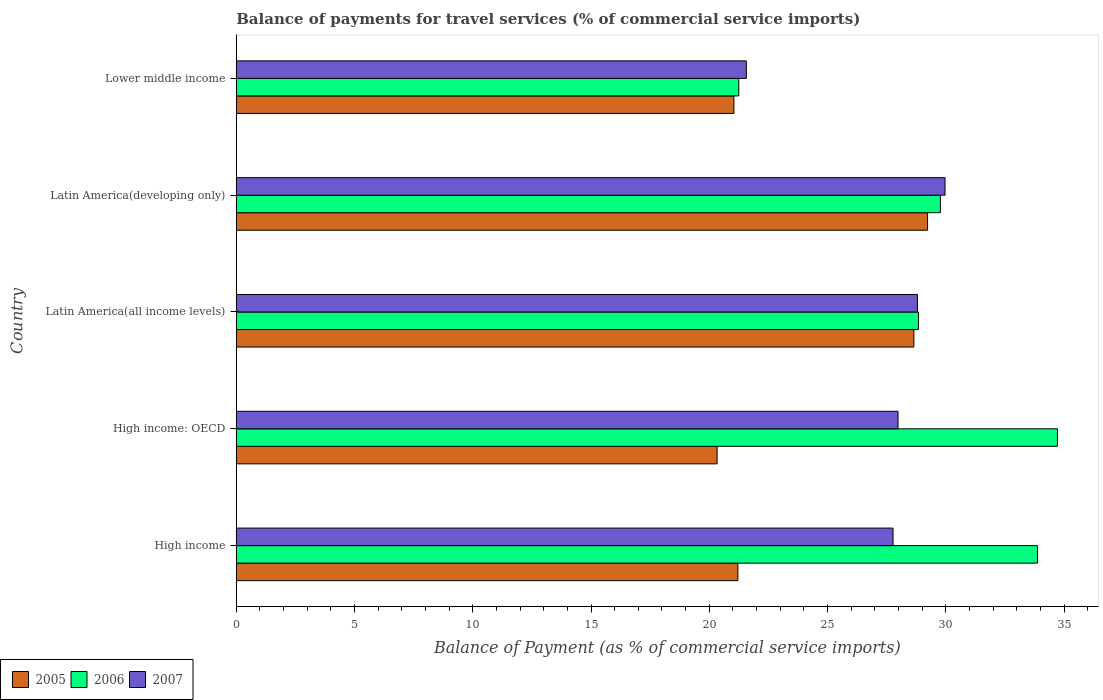What is the label of the 4th group of bars from the top?
Your response must be concise. High income: OECD. In how many cases, is the number of bars for a given country not equal to the number of legend labels?
Make the answer very short. 0. What is the balance of payments for travel services in 2006 in High income?
Your response must be concise. 33.88. Across all countries, what is the maximum balance of payments for travel services in 2005?
Provide a short and direct response. 29.23. Across all countries, what is the minimum balance of payments for travel services in 2007?
Keep it short and to the point. 21.57. In which country was the balance of payments for travel services in 2006 maximum?
Your answer should be compact. High income: OECD. In which country was the balance of payments for travel services in 2005 minimum?
Make the answer very short. High income: OECD. What is the total balance of payments for travel services in 2007 in the graph?
Keep it short and to the point. 136.08. What is the difference between the balance of payments for travel services in 2006 in High income and that in High income: OECD?
Make the answer very short. -0.84. What is the difference between the balance of payments for travel services in 2005 in Latin America(all income levels) and the balance of payments for travel services in 2007 in Latin America(developing only)?
Make the answer very short. -1.32. What is the average balance of payments for travel services in 2006 per country?
Ensure brevity in your answer.  29.69. What is the difference between the balance of payments for travel services in 2006 and balance of payments for travel services in 2007 in High income: OECD?
Your answer should be compact. 6.74. In how many countries, is the balance of payments for travel services in 2005 greater than 23 %?
Ensure brevity in your answer.  2. What is the ratio of the balance of payments for travel services in 2005 in Latin America(all income levels) to that in Lower middle income?
Your answer should be very brief. 1.36. Is the balance of payments for travel services in 2006 in Latin America(all income levels) less than that in Latin America(developing only)?
Provide a succinct answer. Yes. Is the difference between the balance of payments for travel services in 2006 in High income: OECD and Latin America(all income levels) greater than the difference between the balance of payments for travel services in 2007 in High income: OECD and Latin America(all income levels)?
Provide a succinct answer. Yes. What is the difference between the highest and the second highest balance of payments for travel services in 2007?
Provide a succinct answer. 1.17. What is the difference between the highest and the lowest balance of payments for travel services in 2007?
Ensure brevity in your answer.  8.4. How many countries are there in the graph?
Give a very brief answer. 5. Does the graph contain grids?
Ensure brevity in your answer.  No. How many legend labels are there?
Your response must be concise. 3. What is the title of the graph?
Give a very brief answer. Balance of payments for travel services (% of commercial service imports). What is the label or title of the X-axis?
Your answer should be very brief. Balance of Payment (as % of commercial service imports). What is the Balance of Payment (as % of commercial service imports) in 2005 in High income?
Offer a very short reply. 21.21. What is the Balance of Payment (as % of commercial service imports) in 2006 in High income?
Keep it short and to the point. 33.88. What is the Balance of Payment (as % of commercial service imports) of 2007 in High income?
Provide a succinct answer. 27.77. What is the Balance of Payment (as % of commercial service imports) of 2005 in High income: OECD?
Make the answer very short. 20.33. What is the Balance of Payment (as % of commercial service imports) in 2006 in High income: OECD?
Give a very brief answer. 34.72. What is the Balance of Payment (as % of commercial service imports) in 2007 in High income: OECD?
Make the answer very short. 27.98. What is the Balance of Payment (as % of commercial service imports) of 2005 in Latin America(all income levels)?
Your answer should be very brief. 28.65. What is the Balance of Payment (as % of commercial service imports) of 2006 in Latin America(all income levels)?
Your answer should be compact. 28.84. What is the Balance of Payment (as % of commercial service imports) of 2007 in Latin America(all income levels)?
Your answer should be very brief. 28.8. What is the Balance of Payment (as % of commercial service imports) of 2005 in Latin America(developing only)?
Offer a terse response. 29.23. What is the Balance of Payment (as % of commercial service imports) of 2006 in Latin America(developing only)?
Ensure brevity in your answer.  29.77. What is the Balance of Payment (as % of commercial service imports) in 2007 in Latin America(developing only)?
Your response must be concise. 29.97. What is the Balance of Payment (as % of commercial service imports) of 2005 in Lower middle income?
Give a very brief answer. 21.04. What is the Balance of Payment (as % of commercial service imports) in 2006 in Lower middle income?
Keep it short and to the point. 21.25. What is the Balance of Payment (as % of commercial service imports) of 2007 in Lower middle income?
Provide a short and direct response. 21.57. Across all countries, what is the maximum Balance of Payment (as % of commercial service imports) of 2005?
Ensure brevity in your answer.  29.23. Across all countries, what is the maximum Balance of Payment (as % of commercial service imports) of 2006?
Provide a succinct answer. 34.72. Across all countries, what is the maximum Balance of Payment (as % of commercial service imports) in 2007?
Ensure brevity in your answer.  29.97. Across all countries, what is the minimum Balance of Payment (as % of commercial service imports) of 2005?
Make the answer very short. 20.33. Across all countries, what is the minimum Balance of Payment (as % of commercial service imports) of 2006?
Your answer should be very brief. 21.25. Across all countries, what is the minimum Balance of Payment (as % of commercial service imports) of 2007?
Your response must be concise. 21.57. What is the total Balance of Payment (as % of commercial service imports) in 2005 in the graph?
Keep it short and to the point. 120.46. What is the total Balance of Payment (as % of commercial service imports) of 2006 in the graph?
Your answer should be very brief. 148.46. What is the total Balance of Payment (as % of commercial service imports) of 2007 in the graph?
Offer a terse response. 136.08. What is the difference between the Balance of Payment (as % of commercial service imports) in 2005 in High income and that in High income: OECD?
Your answer should be compact. 0.88. What is the difference between the Balance of Payment (as % of commercial service imports) in 2006 in High income and that in High income: OECD?
Provide a short and direct response. -0.84. What is the difference between the Balance of Payment (as % of commercial service imports) of 2007 in High income and that in High income: OECD?
Offer a very short reply. -0.21. What is the difference between the Balance of Payment (as % of commercial service imports) of 2005 in High income and that in Latin America(all income levels)?
Provide a succinct answer. -7.44. What is the difference between the Balance of Payment (as % of commercial service imports) in 2006 in High income and that in Latin America(all income levels)?
Provide a succinct answer. 5.03. What is the difference between the Balance of Payment (as % of commercial service imports) of 2007 in High income and that in Latin America(all income levels)?
Ensure brevity in your answer.  -1.03. What is the difference between the Balance of Payment (as % of commercial service imports) of 2005 in High income and that in Latin America(developing only)?
Ensure brevity in your answer.  -8.02. What is the difference between the Balance of Payment (as % of commercial service imports) in 2006 in High income and that in Latin America(developing only)?
Offer a very short reply. 4.1. What is the difference between the Balance of Payment (as % of commercial service imports) of 2007 in High income and that in Latin America(developing only)?
Offer a terse response. -2.2. What is the difference between the Balance of Payment (as % of commercial service imports) of 2005 in High income and that in Lower middle income?
Give a very brief answer. 0.17. What is the difference between the Balance of Payment (as % of commercial service imports) in 2006 in High income and that in Lower middle income?
Your response must be concise. 12.63. What is the difference between the Balance of Payment (as % of commercial service imports) in 2007 in High income and that in Lower middle income?
Offer a terse response. 6.2. What is the difference between the Balance of Payment (as % of commercial service imports) in 2005 in High income: OECD and that in Latin America(all income levels)?
Provide a succinct answer. -8.32. What is the difference between the Balance of Payment (as % of commercial service imports) of 2006 in High income: OECD and that in Latin America(all income levels)?
Make the answer very short. 5.88. What is the difference between the Balance of Payment (as % of commercial service imports) in 2007 in High income: OECD and that in Latin America(all income levels)?
Provide a succinct answer. -0.82. What is the difference between the Balance of Payment (as % of commercial service imports) in 2005 in High income: OECD and that in Latin America(developing only)?
Offer a terse response. -8.9. What is the difference between the Balance of Payment (as % of commercial service imports) in 2006 in High income: OECD and that in Latin America(developing only)?
Make the answer very short. 4.95. What is the difference between the Balance of Payment (as % of commercial service imports) of 2007 in High income: OECD and that in Latin America(developing only)?
Keep it short and to the point. -1.99. What is the difference between the Balance of Payment (as % of commercial service imports) in 2005 in High income: OECD and that in Lower middle income?
Your response must be concise. -0.71. What is the difference between the Balance of Payment (as % of commercial service imports) in 2006 in High income: OECD and that in Lower middle income?
Provide a succinct answer. 13.47. What is the difference between the Balance of Payment (as % of commercial service imports) of 2007 in High income: OECD and that in Lower middle income?
Ensure brevity in your answer.  6.41. What is the difference between the Balance of Payment (as % of commercial service imports) in 2005 in Latin America(all income levels) and that in Latin America(developing only)?
Offer a very short reply. -0.58. What is the difference between the Balance of Payment (as % of commercial service imports) in 2006 in Latin America(all income levels) and that in Latin America(developing only)?
Offer a very short reply. -0.93. What is the difference between the Balance of Payment (as % of commercial service imports) of 2007 in Latin America(all income levels) and that in Latin America(developing only)?
Keep it short and to the point. -1.17. What is the difference between the Balance of Payment (as % of commercial service imports) in 2005 in Latin America(all income levels) and that in Lower middle income?
Ensure brevity in your answer.  7.61. What is the difference between the Balance of Payment (as % of commercial service imports) of 2006 in Latin America(all income levels) and that in Lower middle income?
Offer a terse response. 7.6. What is the difference between the Balance of Payment (as % of commercial service imports) in 2007 in Latin America(all income levels) and that in Lower middle income?
Give a very brief answer. 7.23. What is the difference between the Balance of Payment (as % of commercial service imports) of 2005 in Latin America(developing only) and that in Lower middle income?
Ensure brevity in your answer.  8.19. What is the difference between the Balance of Payment (as % of commercial service imports) in 2006 in Latin America(developing only) and that in Lower middle income?
Your response must be concise. 8.53. What is the difference between the Balance of Payment (as % of commercial service imports) of 2007 in Latin America(developing only) and that in Lower middle income?
Keep it short and to the point. 8.4. What is the difference between the Balance of Payment (as % of commercial service imports) in 2005 in High income and the Balance of Payment (as % of commercial service imports) in 2006 in High income: OECD?
Provide a short and direct response. -13.51. What is the difference between the Balance of Payment (as % of commercial service imports) in 2005 in High income and the Balance of Payment (as % of commercial service imports) in 2007 in High income: OECD?
Your answer should be compact. -6.77. What is the difference between the Balance of Payment (as % of commercial service imports) in 2006 in High income and the Balance of Payment (as % of commercial service imports) in 2007 in High income: OECD?
Your response must be concise. 5.9. What is the difference between the Balance of Payment (as % of commercial service imports) of 2005 in High income and the Balance of Payment (as % of commercial service imports) of 2006 in Latin America(all income levels)?
Provide a succinct answer. -7.63. What is the difference between the Balance of Payment (as % of commercial service imports) in 2005 in High income and the Balance of Payment (as % of commercial service imports) in 2007 in Latin America(all income levels)?
Offer a very short reply. -7.59. What is the difference between the Balance of Payment (as % of commercial service imports) of 2006 in High income and the Balance of Payment (as % of commercial service imports) of 2007 in Latin America(all income levels)?
Offer a very short reply. 5.08. What is the difference between the Balance of Payment (as % of commercial service imports) in 2005 in High income and the Balance of Payment (as % of commercial service imports) in 2006 in Latin America(developing only)?
Ensure brevity in your answer.  -8.56. What is the difference between the Balance of Payment (as % of commercial service imports) of 2005 in High income and the Balance of Payment (as % of commercial service imports) of 2007 in Latin America(developing only)?
Your answer should be compact. -8.76. What is the difference between the Balance of Payment (as % of commercial service imports) of 2006 in High income and the Balance of Payment (as % of commercial service imports) of 2007 in Latin America(developing only)?
Make the answer very short. 3.91. What is the difference between the Balance of Payment (as % of commercial service imports) in 2005 in High income and the Balance of Payment (as % of commercial service imports) in 2006 in Lower middle income?
Offer a terse response. -0.04. What is the difference between the Balance of Payment (as % of commercial service imports) in 2005 in High income and the Balance of Payment (as % of commercial service imports) in 2007 in Lower middle income?
Make the answer very short. -0.36. What is the difference between the Balance of Payment (as % of commercial service imports) in 2006 in High income and the Balance of Payment (as % of commercial service imports) in 2007 in Lower middle income?
Your answer should be very brief. 12.31. What is the difference between the Balance of Payment (as % of commercial service imports) in 2005 in High income: OECD and the Balance of Payment (as % of commercial service imports) in 2006 in Latin America(all income levels)?
Your answer should be very brief. -8.51. What is the difference between the Balance of Payment (as % of commercial service imports) in 2005 in High income: OECD and the Balance of Payment (as % of commercial service imports) in 2007 in Latin America(all income levels)?
Offer a terse response. -8.47. What is the difference between the Balance of Payment (as % of commercial service imports) of 2006 in High income: OECD and the Balance of Payment (as % of commercial service imports) of 2007 in Latin America(all income levels)?
Give a very brief answer. 5.92. What is the difference between the Balance of Payment (as % of commercial service imports) in 2005 in High income: OECD and the Balance of Payment (as % of commercial service imports) in 2006 in Latin America(developing only)?
Your answer should be compact. -9.44. What is the difference between the Balance of Payment (as % of commercial service imports) in 2005 in High income: OECD and the Balance of Payment (as % of commercial service imports) in 2007 in Latin America(developing only)?
Your answer should be compact. -9.64. What is the difference between the Balance of Payment (as % of commercial service imports) in 2006 in High income: OECD and the Balance of Payment (as % of commercial service imports) in 2007 in Latin America(developing only)?
Provide a short and direct response. 4.75. What is the difference between the Balance of Payment (as % of commercial service imports) of 2005 in High income: OECD and the Balance of Payment (as % of commercial service imports) of 2006 in Lower middle income?
Offer a very short reply. -0.92. What is the difference between the Balance of Payment (as % of commercial service imports) of 2005 in High income: OECD and the Balance of Payment (as % of commercial service imports) of 2007 in Lower middle income?
Provide a succinct answer. -1.24. What is the difference between the Balance of Payment (as % of commercial service imports) in 2006 in High income: OECD and the Balance of Payment (as % of commercial service imports) in 2007 in Lower middle income?
Give a very brief answer. 13.15. What is the difference between the Balance of Payment (as % of commercial service imports) of 2005 in Latin America(all income levels) and the Balance of Payment (as % of commercial service imports) of 2006 in Latin America(developing only)?
Give a very brief answer. -1.12. What is the difference between the Balance of Payment (as % of commercial service imports) of 2005 in Latin America(all income levels) and the Balance of Payment (as % of commercial service imports) of 2007 in Latin America(developing only)?
Offer a very short reply. -1.32. What is the difference between the Balance of Payment (as % of commercial service imports) in 2006 in Latin America(all income levels) and the Balance of Payment (as % of commercial service imports) in 2007 in Latin America(developing only)?
Offer a terse response. -1.12. What is the difference between the Balance of Payment (as % of commercial service imports) in 2005 in Latin America(all income levels) and the Balance of Payment (as % of commercial service imports) in 2006 in Lower middle income?
Offer a very short reply. 7.4. What is the difference between the Balance of Payment (as % of commercial service imports) in 2005 in Latin America(all income levels) and the Balance of Payment (as % of commercial service imports) in 2007 in Lower middle income?
Your response must be concise. 7.08. What is the difference between the Balance of Payment (as % of commercial service imports) of 2006 in Latin America(all income levels) and the Balance of Payment (as % of commercial service imports) of 2007 in Lower middle income?
Provide a succinct answer. 7.28. What is the difference between the Balance of Payment (as % of commercial service imports) in 2005 in Latin America(developing only) and the Balance of Payment (as % of commercial service imports) in 2006 in Lower middle income?
Give a very brief answer. 7.98. What is the difference between the Balance of Payment (as % of commercial service imports) in 2005 in Latin America(developing only) and the Balance of Payment (as % of commercial service imports) in 2007 in Lower middle income?
Give a very brief answer. 7.66. What is the difference between the Balance of Payment (as % of commercial service imports) of 2006 in Latin America(developing only) and the Balance of Payment (as % of commercial service imports) of 2007 in Lower middle income?
Offer a terse response. 8.2. What is the average Balance of Payment (as % of commercial service imports) in 2005 per country?
Offer a very short reply. 24.09. What is the average Balance of Payment (as % of commercial service imports) of 2006 per country?
Your answer should be compact. 29.69. What is the average Balance of Payment (as % of commercial service imports) in 2007 per country?
Give a very brief answer. 27.22. What is the difference between the Balance of Payment (as % of commercial service imports) of 2005 and Balance of Payment (as % of commercial service imports) of 2006 in High income?
Give a very brief answer. -12.67. What is the difference between the Balance of Payment (as % of commercial service imports) in 2005 and Balance of Payment (as % of commercial service imports) in 2007 in High income?
Provide a short and direct response. -6.56. What is the difference between the Balance of Payment (as % of commercial service imports) of 2006 and Balance of Payment (as % of commercial service imports) of 2007 in High income?
Your answer should be very brief. 6.11. What is the difference between the Balance of Payment (as % of commercial service imports) of 2005 and Balance of Payment (as % of commercial service imports) of 2006 in High income: OECD?
Make the answer very short. -14.39. What is the difference between the Balance of Payment (as % of commercial service imports) of 2005 and Balance of Payment (as % of commercial service imports) of 2007 in High income: OECD?
Offer a terse response. -7.65. What is the difference between the Balance of Payment (as % of commercial service imports) in 2006 and Balance of Payment (as % of commercial service imports) in 2007 in High income: OECD?
Give a very brief answer. 6.74. What is the difference between the Balance of Payment (as % of commercial service imports) of 2005 and Balance of Payment (as % of commercial service imports) of 2006 in Latin America(all income levels)?
Ensure brevity in your answer.  -0.19. What is the difference between the Balance of Payment (as % of commercial service imports) of 2005 and Balance of Payment (as % of commercial service imports) of 2007 in Latin America(all income levels)?
Offer a very short reply. -0.15. What is the difference between the Balance of Payment (as % of commercial service imports) of 2006 and Balance of Payment (as % of commercial service imports) of 2007 in Latin America(all income levels)?
Provide a succinct answer. 0.04. What is the difference between the Balance of Payment (as % of commercial service imports) in 2005 and Balance of Payment (as % of commercial service imports) in 2006 in Latin America(developing only)?
Your answer should be compact. -0.54. What is the difference between the Balance of Payment (as % of commercial service imports) of 2005 and Balance of Payment (as % of commercial service imports) of 2007 in Latin America(developing only)?
Your response must be concise. -0.74. What is the difference between the Balance of Payment (as % of commercial service imports) of 2006 and Balance of Payment (as % of commercial service imports) of 2007 in Latin America(developing only)?
Make the answer very short. -0.2. What is the difference between the Balance of Payment (as % of commercial service imports) of 2005 and Balance of Payment (as % of commercial service imports) of 2006 in Lower middle income?
Ensure brevity in your answer.  -0.2. What is the difference between the Balance of Payment (as % of commercial service imports) of 2005 and Balance of Payment (as % of commercial service imports) of 2007 in Lower middle income?
Keep it short and to the point. -0.53. What is the difference between the Balance of Payment (as % of commercial service imports) in 2006 and Balance of Payment (as % of commercial service imports) in 2007 in Lower middle income?
Provide a short and direct response. -0.32. What is the ratio of the Balance of Payment (as % of commercial service imports) of 2005 in High income to that in High income: OECD?
Your response must be concise. 1.04. What is the ratio of the Balance of Payment (as % of commercial service imports) of 2006 in High income to that in High income: OECD?
Provide a short and direct response. 0.98. What is the ratio of the Balance of Payment (as % of commercial service imports) in 2005 in High income to that in Latin America(all income levels)?
Ensure brevity in your answer.  0.74. What is the ratio of the Balance of Payment (as % of commercial service imports) in 2006 in High income to that in Latin America(all income levels)?
Provide a succinct answer. 1.17. What is the ratio of the Balance of Payment (as % of commercial service imports) in 2007 in High income to that in Latin America(all income levels)?
Keep it short and to the point. 0.96. What is the ratio of the Balance of Payment (as % of commercial service imports) of 2005 in High income to that in Latin America(developing only)?
Your answer should be compact. 0.73. What is the ratio of the Balance of Payment (as % of commercial service imports) of 2006 in High income to that in Latin America(developing only)?
Your answer should be compact. 1.14. What is the ratio of the Balance of Payment (as % of commercial service imports) in 2007 in High income to that in Latin America(developing only)?
Offer a very short reply. 0.93. What is the ratio of the Balance of Payment (as % of commercial service imports) of 2005 in High income to that in Lower middle income?
Make the answer very short. 1.01. What is the ratio of the Balance of Payment (as % of commercial service imports) of 2006 in High income to that in Lower middle income?
Your response must be concise. 1.59. What is the ratio of the Balance of Payment (as % of commercial service imports) in 2007 in High income to that in Lower middle income?
Your response must be concise. 1.29. What is the ratio of the Balance of Payment (as % of commercial service imports) in 2005 in High income: OECD to that in Latin America(all income levels)?
Ensure brevity in your answer.  0.71. What is the ratio of the Balance of Payment (as % of commercial service imports) in 2006 in High income: OECD to that in Latin America(all income levels)?
Provide a succinct answer. 1.2. What is the ratio of the Balance of Payment (as % of commercial service imports) of 2007 in High income: OECD to that in Latin America(all income levels)?
Your answer should be very brief. 0.97. What is the ratio of the Balance of Payment (as % of commercial service imports) in 2005 in High income: OECD to that in Latin America(developing only)?
Offer a terse response. 0.7. What is the ratio of the Balance of Payment (as % of commercial service imports) of 2006 in High income: OECD to that in Latin America(developing only)?
Ensure brevity in your answer.  1.17. What is the ratio of the Balance of Payment (as % of commercial service imports) of 2007 in High income: OECD to that in Latin America(developing only)?
Make the answer very short. 0.93. What is the ratio of the Balance of Payment (as % of commercial service imports) in 2005 in High income: OECD to that in Lower middle income?
Your answer should be very brief. 0.97. What is the ratio of the Balance of Payment (as % of commercial service imports) of 2006 in High income: OECD to that in Lower middle income?
Make the answer very short. 1.63. What is the ratio of the Balance of Payment (as % of commercial service imports) in 2007 in High income: OECD to that in Lower middle income?
Make the answer very short. 1.3. What is the ratio of the Balance of Payment (as % of commercial service imports) in 2005 in Latin America(all income levels) to that in Latin America(developing only)?
Provide a short and direct response. 0.98. What is the ratio of the Balance of Payment (as % of commercial service imports) of 2006 in Latin America(all income levels) to that in Latin America(developing only)?
Provide a succinct answer. 0.97. What is the ratio of the Balance of Payment (as % of commercial service imports) of 2007 in Latin America(all income levels) to that in Latin America(developing only)?
Give a very brief answer. 0.96. What is the ratio of the Balance of Payment (as % of commercial service imports) of 2005 in Latin America(all income levels) to that in Lower middle income?
Offer a terse response. 1.36. What is the ratio of the Balance of Payment (as % of commercial service imports) in 2006 in Latin America(all income levels) to that in Lower middle income?
Your answer should be compact. 1.36. What is the ratio of the Balance of Payment (as % of commercial service imports) of 2007 in Latin America(all income levels) to that in Lower middle income?
Provide a short and direct response. 1.34. What is the ratio of the Balance of Payment (as % of commercial service imports) of 2005 in Latin America(developing only) to that in Lower middle income?
Ensure brevity in your answer.  1.39. What is the ratio of the Balance of Payment (as % of commercial service imports) in 2006 in Latin America(developing only) to that in Lower middle income?
Keep it short and to the point. 1.4. What is the ratio of the Balance of Payment (as % of commercial service imports) of 2007 in Latin America(developing only) to that in Lower middle income?
Your answer should be very brief. 1.39. What is the difference between the highest and the second highest Balance of Payment (as % of commercial service imports) of 2005?
Make the answer very short. 0.58. What is the difference between the highest and the second highest Balance of Payment (as % of commercial service imports) in 2006?
Provide a short and direct response. 0.84. What is the difference between the highest and the second highest Balance of Payment (as % of commercial service imports) in 2007?
Provide a succinct answer. 1.17. What is the difference between the highest and the lowest Balance of Payment (as % of commercial service imports) in 2005?
Ensure brevity in your answer.  8.9. What is the difference between the highest and the lowest Balance of Payment (as % of commercial service imports) in 2006?
Provide a short and direct response. 13.47. What is the difference between the highest and the lowest Balance of Payment (as % of commercial service imports) in 2007?
Provide a short and direct response. 8.4. 